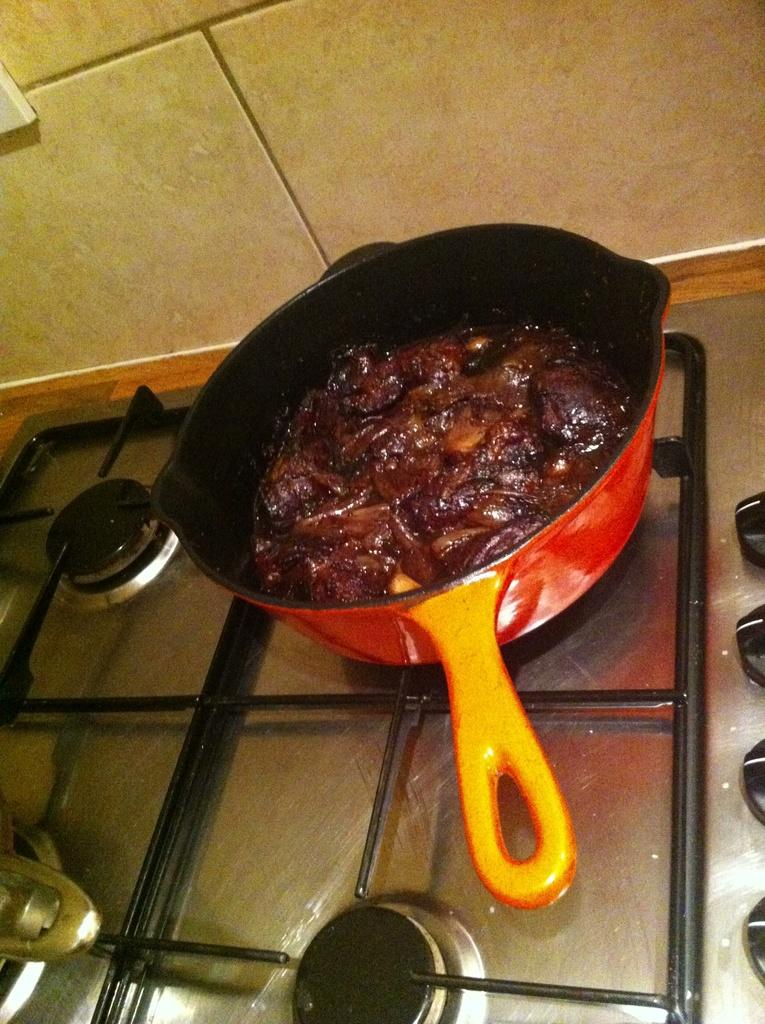What color is the pan that is visible in the image? There is a red pan in the image. What is on the red pan in the image? Food items are present on the red pan. Where is the red pan located in the image? The red pan is kept on a stove. What type of flooring can be seen in the background of the image? There are tiles visible in the background of the image. What type of poison is being used to cook the food on the red pan? There is no mention of poison in the image, and it is not being used to cook the food. 